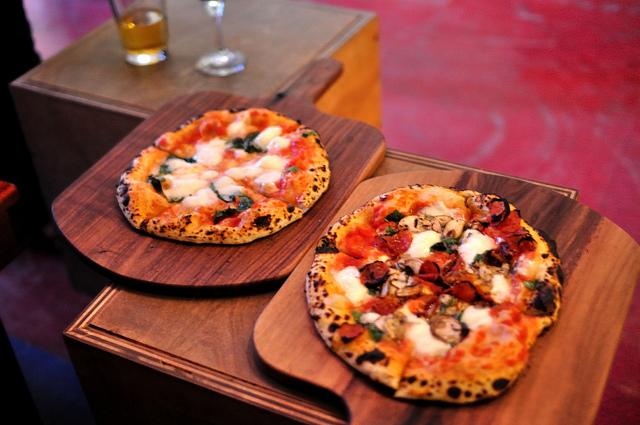Are the pizza paddles facing different directions?
Write a very short answer. Yes. Which of these would you prefer to eat?
Short answer required. Right. Is there a glass of beer nearby?
Concise answer only. Yes. 